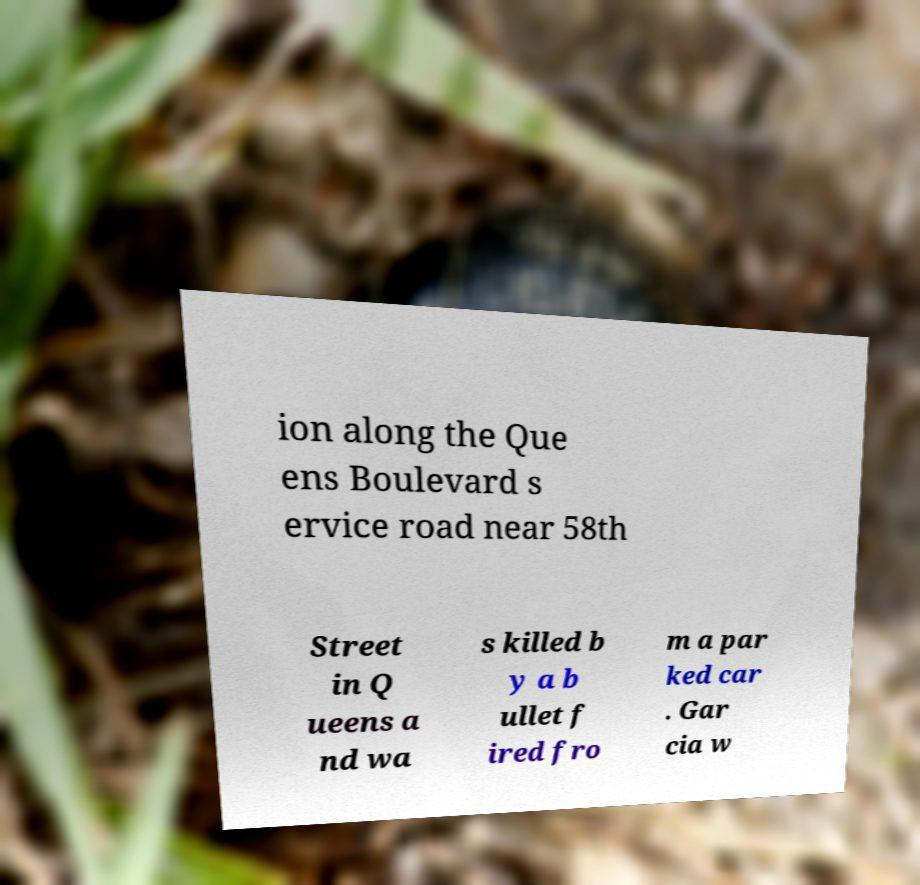Can you accurately transcribe the text from the provided image for me? ion along the Que ens Boulevard s ervice road near 58th Street in Q ueens a nd wa s killed b y a b ullet f ired fro m a par ked car . Gar cia w 